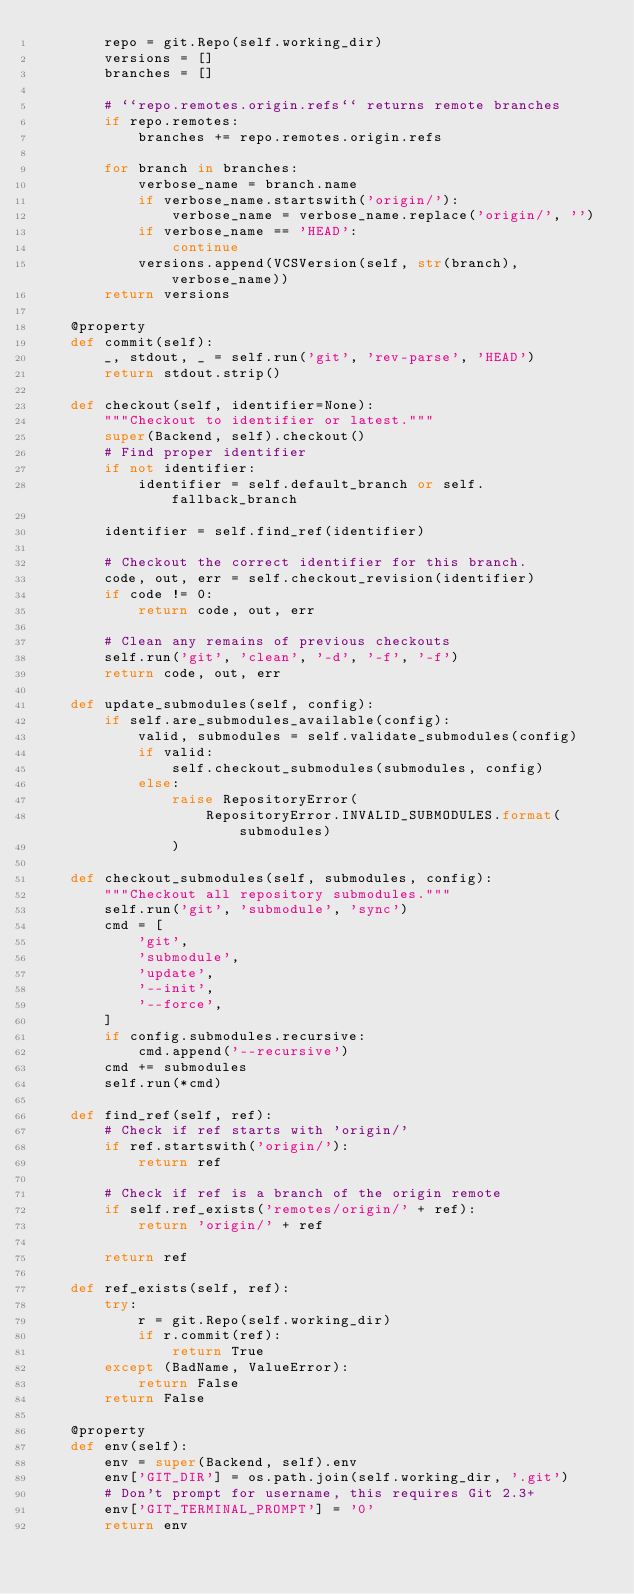<code> <loc_0><loc_0><loc_500><loc_500><_Python_>        repo = git.Repo(self.working_dir)
        versions = []
        branches = []

        # ``repo.remotes.origin.refs`` returns remote branches
        if repo.remotes:
            branches += repo.remotes.origin.refs

        for branch in branches:
            verbose_name = branch.name
            if verbose_name.startswith('origin/'):
                verbose_name = verbose_name.replace('origin/', '')
            if verbose_name == 'HEAD':
                continue
            versions.append(VCSVersion(self, str(branch), verbose_name))
        return versions

    @property
    def commit(self):
        _, stdout, _ = self.run('git', 'rev-parse', 'HEAD')
        return stdout.strip()

    def checkout(self, identifier=None):
        """Checkout to identifier or latest."""
        super(Backend, self).checkout()
        # Find proper identifier
        if not identifier:
            identifier = self.default_branch or self.fallback_branch

        identifier = self.find_ref(identifier)

        # Checkout the correct identifier for this branch.
        code, out, err = self.checkout_revision(identifier)
        if code != 0:
            return code, out, err

        # Clean any remains of previous checkouts
        self.run('git', 'clean', '-d', '-f', '-f')
        return code, out, err

    def update_submodules(self, config):
        if self.are_submodules_available(config):
            valid, submodules = self.validate_submodules(config)
            if valid:
                self.checkout_submodules(submodules, config)
            else:
                raise RepositoryError(
                    RepositoryError.INVALID_SUBMODULES.format(submodules)
                )

    def checkout_submodules(self, submodules, config):
        """Checkout all repository submodules."""
        self.run('git', 'submodule', 'sync')
        cmd = [
            'git',
            'submodule',
            'update',
            '--init',
            '--force',
        ]
        if config.submodules.recursive:
            cmd.append('--recursive')
        cmd += submodules
        self.run(*cmd)

    def find_ref(self, ref):
        # Check if ref starts with 'origin/'
        if ref.startswith('origin/'):
            return ref

        # Check if ref is a branch of the origin remote
        if self.ref_exists('remotes/origin/' + ref):
            return 'origin/' + ref

        return ref

    def ref_exists(self, ref):
        try:
            r = git.Repo(self.working_dir)
            if r.commit(ref):
                return True
        except (BadName, ValueError):
            return False
        return False

    @property
    def env(self):
        env = super(Backend, self).env
        env['GIT_DIR'] = os.path.join(self.working_dir, '.git')
        # Don't prompt for username, this requires Git 2.3+
        env['GIT_TERMINAL_PROMPT'] = '0'
        return env
</code> 